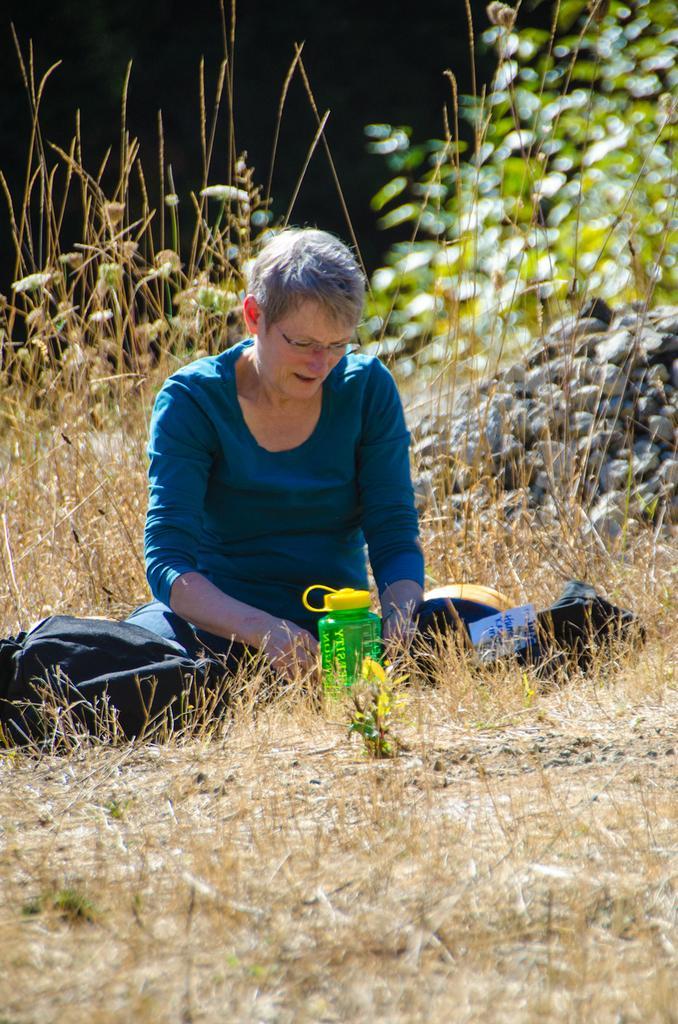Could you give a brief overview of what you see in this image? In this picture we can see a woman is seated on the grass, in front of her we can find a bottle and couple of bags, in the background we can see couple of plants. 